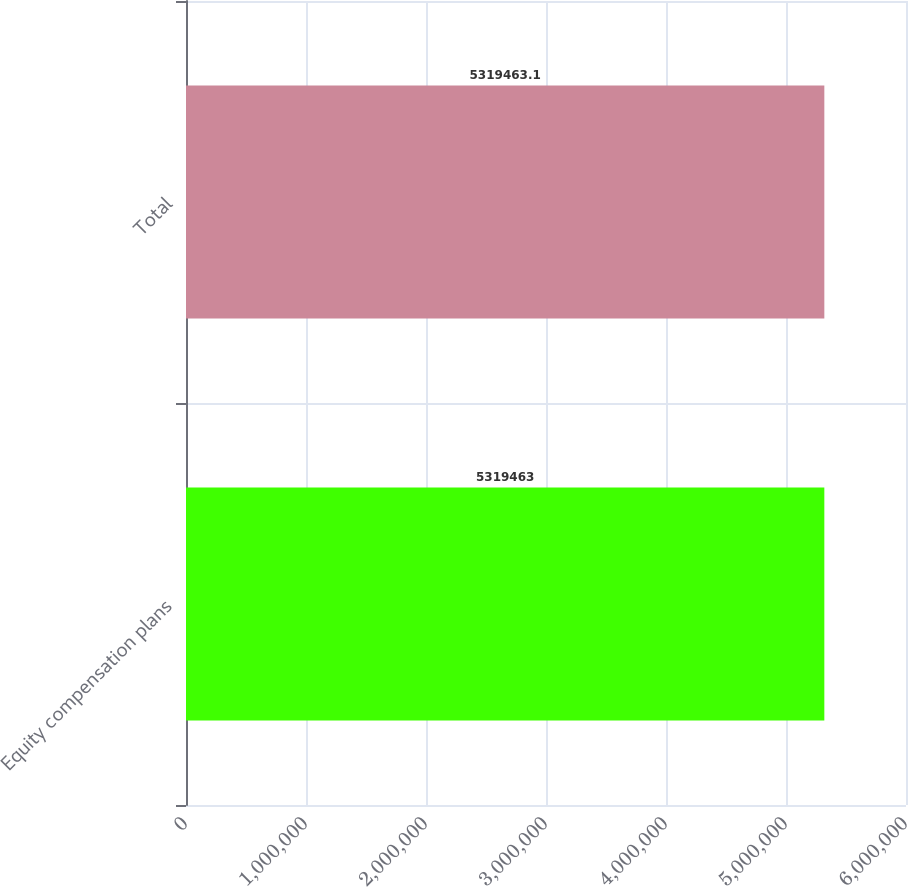<chart> <loc_0><loc_0><loc_500><loc_500><bar_chart><fcel>Equity compensation plans<fcel>Total<nl><fcel>5.31946e+06<fcel>5.31946e+06<nl></chart> 